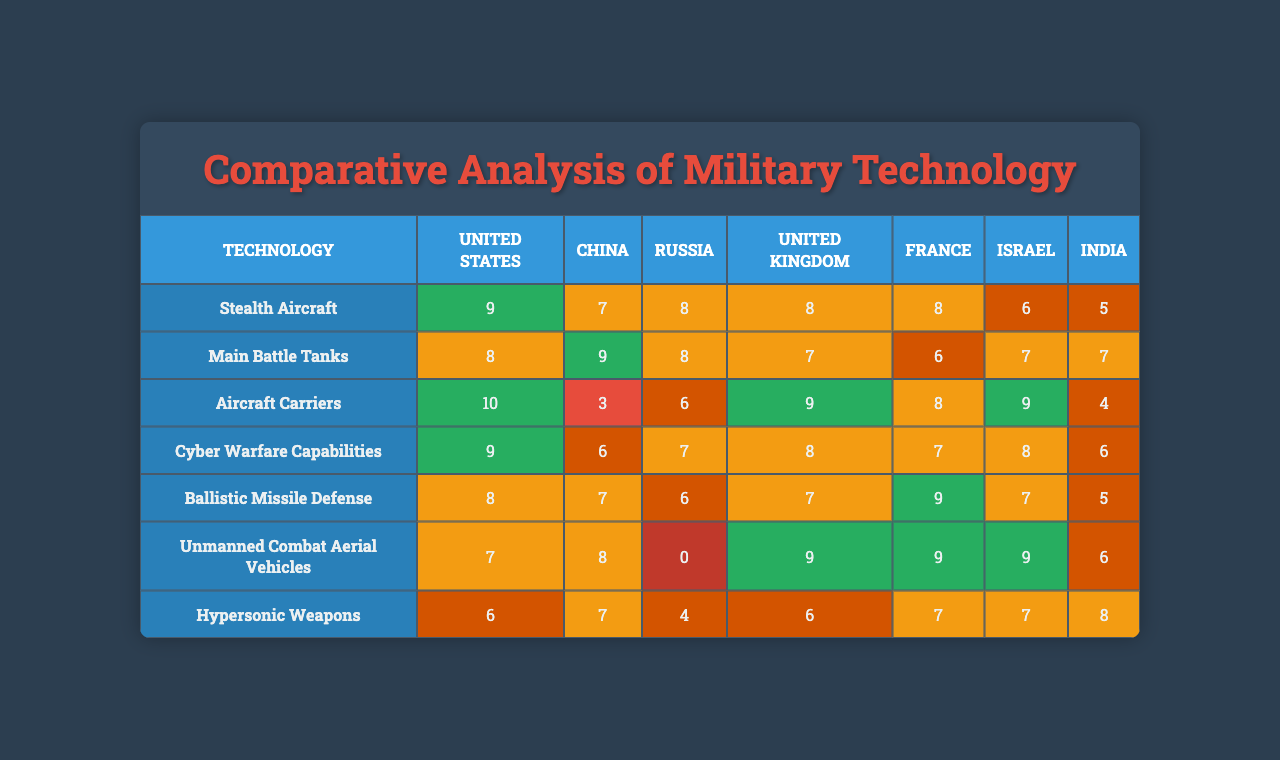What country has the highest rating for Stealth Aircraft? Looking at the row for Stealth Aircraft, the United States has a rating of 9, which is the highest compared to other countries in that category.
Answer: United States Which country has the lowest rating in Unmanned Combat Aerial Vehicles? In the row for Unmanned Combat Aerial Vehicles, Russia has a rating of 0, which is lower than all other countries.
Answer: Russia What is the average rating for the Main Battle Tanks across all countries? The ratings for Main Battle Tanks are 7, 9, 3, 6, 7, 8, and 7. Summing these ratings gives 47, and dividing by 7 (the number of countries) results in an average rating of approximately 6.71.
Answer: 6.71 Does China have a better rating than India in Ballistic Missile Defense? China has a rating of 6 and India has a rating of 7 in Ballistic Missile Defense. Since 6 is less than 7, the statement is false.
Answer: No Which country has the second highest aggregate ratings across all technologies? First, we sum the ratings for each country: United States (54), China (55), Russia (39), United Kingdom (46), France (42), Israel (47), India (46). The second highest is China with a total of 55.
Answer: China How many countries have a rating of 7 or above in Cyber Warfare Capabilities? The ratings for Cyber Warfare Capabilities are 8 (US), 7 (China), 9 (Russia), 8 (UK), 7 (France), 9 (Israel), and 6 (India). This shows that there are 5 countries (US, China, Russia, UK, Israel) with ratings of 7 or above.
Answer: 5 What is the difference between the highest and lowest ratings for Hypersonic Weapons? The highest rating for Hypersonic Weapons is 10 (United States) and the lowest is 4 (Russia). The difference is calculated as 10 - 4 = 6.
Answer: 6 Which technology does Israel excel most in compared to other countries? A look at Israel’s ratings reveals it has the highest rating in Cyber Warfare Capabilities (9) compared to the other countries.
Answer: Cyber Warfare Capabilities Are there any countries that have the same rating for Aircraft Carriers? The ratings for Aircraft Carriers are 8 (US), 8 (China), 6 (Russia), 8 (UK), 7 (France), 0 (Israel), and 4 (India). This shows that the US, China, and UK have the same rating of 8.
Answer: Yes What percentage of the technologies have a rating of 8 or above from the United States? The ratings for the US are 9, 8, 10, 9, 8, 7, and 6. Out of 7 technologies, 5 have a rating of 8 or above. The percentage is (5/7) * 100 = approximately 71.43%.
Answer: 71.43% 